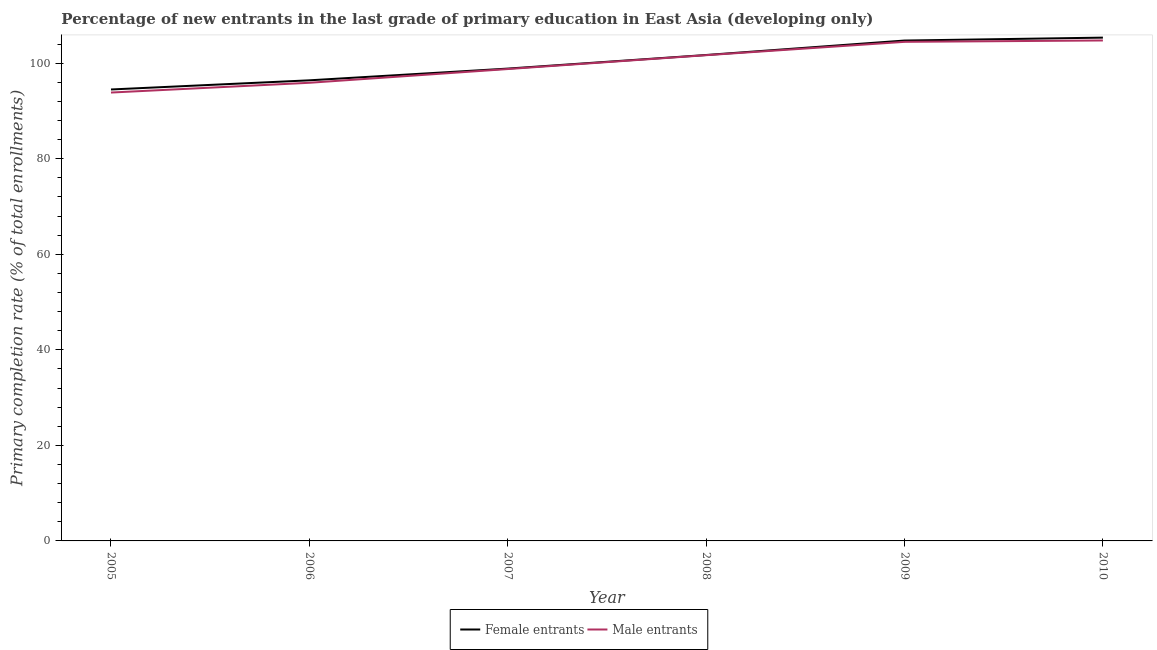Does the line corresponding to primary completion rate of female entrants intersect with the line corresponding to primary completion rate of male entrants?
Provide a short and direct response. No. Is the number of lines equal to the number of legend labels?
Your answer should be very brief. Yes. What is the primary completion rate of female entrants in 2009?
Your answer should be very brief. 104.75. Across all years, what is the maximum primary completion rate of male entrants?
Provide a short and direct response. 104.76. Across all years, what is the minimum primary completion rate of female entrants?
Ensure brevity in your answer.  94.5. In which year was the primary completion rate of female entrants maximum?
Your answer should be compact. 2010. What is the total primary completion rate of female entrants in the graph?
Your response must be concise. 601.63. What is the difference between the primary completion rate of male entrants in 2007 and that in 2009?
Make the answer very short. -5.69. What is the difference between the primary completion rate of male entrants in 2009 and the primary completion rate of female entrants in 2006?
Ensure brevity in your answer.  8.05. What is the average primary completion rate of female entrants per year?
Give a very brief answer. 100.27. In the year 2007, what is the difference between the primary completion rate of female entrants and primary completion rate of male entrants?
Your answer should be compact. 0.1. What is the ratio of the primary completion rate of female entrants in 2005 to that in 2008?
Provide a succinct answer. 0.93. Is the primary completion rate of male entrants in 2006 less than that in 2008?
Give a very brief answer. Yes. Is the difference between the primary completion rate of female entrants in 2007 and 2010 greater than the difference between the primary completion rate of male entrants in 2007 and 2010?
Ensure brevity in your answer.  No. What is the difference between the highest and the second highest primary completion rate of male entrants?
Your answer should be very brief. 0.29. What is the difference between the highest and the lowest primary completion rate of male entrants?
Your response must be concise. 10.9. Does the primary completion rate of male entrants monotonically increase over the years?
Provide a short and direct response. Yes. Is the primary completion rate of female entrants strictly less than the primary completion rate of male entrants over the years?
Provide a short and direct response. No. How many years are there in the graph?
Provide a succinct answer. 6. What is the difference between two consecutive major ticks on the Y-axis?
Provide a short and direct response. 20. Are the values on the major ticks of Y-axis written in scientific E-notation?
Ensure brevity in your answer.  No. Does the graph contain any zero values?
Your response must be concise. No. How are the legend labels stacked?
Provide a succinct answer. Horizontal. What is the title of the graph?
Offer a very short reply. Percentage of new entrants in the last grade of primary education in East Asia (developing only). What is the label or title of the X-axis?
Ensure brevity in your answer.  Year. What is the label or title of the Y-axis?
Ensure brevity in your answer.  Primary completion rate (% of total enrollments). What is the Primary completion rate (% of total enrollments) in Female entrants in 2005?
Ensure brevity in your answer.  94.5. What is the Primary completion rate (% of total enrollments) in Male entrants in 2005?
Provide a short and direct response. 93.86. What is the Primary completion rate (% of total enrollments) of Female entrants in 2006?
Ensure brevity in your answer.  96.42. What is the Primary completion rate (% of total enrollments) of Male entrants in 2006?
Your response must be concise. 95.91. What is the Primary completion rate (% of total enrollments) in Female entrants in 2007?
Keep it short and to the point. 98.88. What is the Primary completion rate (% of total enrollments) in Male entrants in 2007?
Your answer should be compact. 98.78. What is the Primary completion rate (% of total enrollments) of Female entrants in 2008?
Your answer should be compact. 101.72. What is the Primary completion rate (% of total enrollments) of Male entrants in 2008?
Give a very brief answer. 101.68. What is the Primary completion rate (% of total enrollments) of Female entrants in 2009?
Ensure brevity in your answer.  104.75. What is the Primary completion rate (% of total enrollments) in Male entrants in 2009?
Give a very brief answer. 104.48. What is the Primary completion rate (% of total enrollments) in Female entrants in 2010?
Ensure brevity in your answer.  105.36. What is the Primary completion rate (% of total enrollments) in Male entrants in 2010?
Keep it short and to the point. 104.76. Across all years, what is the maximum Primary completion rate (% of total enrollments) in Female entrants?
Your response must be concise. 105.36. Across all years, what is the maximum Primary completion rate (% of total enrollments) in Male entrants?
Offer a very short reply. 104.76. Across all years, what is the minimum Primary completion rate (% of total enrollments) in Female entrants?
Offer a very short reply. 94.5. Across all years, what is the minimum Primary completion rate (% of total enrollments) in Male entrants?
Give a very brief answer. 93.86. What is the total Primary completion rate (% of total enrollments) in Female entrants in the graph?
Your answer should be very brief. 601.63. What is the total Primary completion rate (% of total enrollments) of Male entrants in the graph?
Your answer should be very brief. 599.47. What is the difference between the Primary completion rate (% of total enrollments) of Female entrants in 2005 and that in 2006?
Your answer should be compact. -1.92. What is the difference between the Primary completion rate (% of total enrollments) of Male entrants in 2005 and that in 2006?
Provide a succinct answer. -2.04. What is the difference between the Primary completion rate (% of total enrollments) of Female entrants in 2005 and that in 2007?
Offer a very short reply. -4.37. What is the difference between the Primary completion rate (% of total enrollments) of Male entrants in 2005 and that in 2007?
Ensure brevity in your answer.  -4.92. What is the difference between the Primary completion rate (% of total enrollments) in Female entrants in 2005 and that in 2008?
Offer a terse response. -7.22. What is the difference between the Primary completion rate (% of total enrollments) of Male entrants in 2005 and that in 2008?
Make the answer very short. -7.82. What is the difference between the Primary completion rate (% of total enrollments) of Female entrants in 2005 and that in 2009?
Give a very brief answer. -10.24. What is the difference between the Primary completion rate (% of total enrollments) of Male entrants in 2005 and that in 2009?
Your answer should be very brief. -10.61. What is the difference between the Primary completion rate (% of total enrollments) of Female entrants in 2005 and that in 2010?
Ensure brevity in your answer.  -10.86. What is the difference between the Primary completion rate (% of total enrollments) of Male entrants in 2005 and that in 2010?
Your answer should be compact. -10.9. What is the difference between the Primary completion rate (% of total enrollments) of Female entrants in 2006 and that in 2007?
Keep it short and to the point. -2.46. What is the difference between the Primary completion rate (% of total enrollments) in Male entrants in 2006 and that in 2007?
Give a very brief answer. -2.88. What is the difference between the Primary completion rate (% of total enrollments) of Female entrants in 2006 and that in 2008?
Offer a terse response. -5.3. What is the difference between the Primary completion rate (% of total enrollments) in Male entrants in 2006 and that in 2008?
Your answer should be very brief. -5.78. What is the difference between the Primary completion rate (% of total enrollments) in Female entrants in 2006 and that in 2009?
Offer a terse response. -8.33. What is the difference between the Primary completion rate (% of total enrollments) in Male entrants in 2006 and that in 2009?
Make the answer very short. -8.57. What is the difference between the Primary completion rate (% of total enrollments) of Female entrants in 2006 and that in 2010?
Keep it short and to the point. -8.94. What is the difference between the Primary completion rate (% of total enrollments) of Male entrants in 2006 and that in 2010?
Provide a short and direct response. -8.86. What is the difference between the Primary completion rate (% of total enrollments) in Female entrants in 2007 and that in 2008?
Your answer should be very brief. -2.85. What is the difference between the Primary completion rate (% of total enrollments) of Male entrants in 2007 and that in 2008?
Ensure brevity in your answer.  -2.9. What is the difference between the Primary completion rate (% of total enrollments) of Female entrants in 2007 and that in 2009?
Your answer should be very brief. -5.87. What is the difference between the Primary completion rate (% of total enrollments) in Male entrants in 2007 and that in 2009?
Offer a terse response. -5.69. What is the difference between the Primary completion rate (% of total enrollments) of Female entrants in 2007 and that in 2010?
Offer a very short reply. -6.48. What is the difference between the Primary completion rate (% of total enrollments) of Male entrants in 2007 and that in 2010?
Provide a short and direct response. -5.98. What is the difference between the Primary completion rate (% of total enrollments) of Female entrants in 2008 and that in 2009?
Make the answer very short. -3.02. What is the difference between the Primary completion rate (% of total enrollments) in Male entrants in 2008 and that in 2009?
Give a very brief answer. -2.79. What is the difference between the Primary completion rate (% of total enrollments) of Female entrants in 2008 and that in 2010?
Your response must be concise. -3.64. What is the difference between the Primary completion rate (% of total enrollments) in Male entrants in 2008 and that in 2010?
Your response must be concise. -3.08. What is the difference between the Primary completion rate (% of total enrollments) of Female entrants in 2009 and that in 2010?
Give a very brief answer. -0.61. What is the difference between the Primary completion rate (% of total enrollments) in Male entrants in 2009 and that in 2010?
Your answer should be compact. -0.29. What is the difference between the Primary completion rate (% of total enrollments) in Female entrants in 2005 and the Primary completion rate (% of total enrollments) in Male entrants in 2006?
Give a very brief answer. -1.4. What is the difference between the Primary completion rate (% of total enrollments) of Female entrants in 2005 and the Primary completion rate (% of total enrollments) of Male entrants in 2007?
Make the answer very short. -4.28. What is the difference between the Primary completion rate (% of total enrollments) of Female entrants in 2005 and the Primary completion rate (% of total enrollments) of Male entrants in 2008?
Offer a very short reply. -7.18. What is the difference between the Primary completion rate (% of total enrollments) of Female entrants in 2005 and the Primary completion rate (% of total enrollments) of Male entrants in 2009?
Offer a very short reply. -9.97. What is the difference between the Primary completion rate (% of total enrollments) in Female entrants in 2005 and the Primary completion rate (% of total enrollments) in Male entrants in 2010?
Offer a terse response. -10.26. What is the difference between the Primary completion rate (% of total enrollments) in Female entrants in 2006 and the Primary completion rate (% of total enrollments) in Male entrants in 2007?
Provide a succinct answer. -2.36. What is the difference between the Primary completion rate (% of total enrollments) of Female entrants in 2006 and the Primary completion rate (% of total enrollments) of Male entrants in 2008?
Provide a short and direct response. -5.26. What is the difference between the Primary completion rate (% of total enrollments) of Female entrants in 2006 and the Primary completion rate (% of total enrollments) of Male entrants in 2009?
Give a very brief answer. -8.05. What is the difference between the Primary completion rate (% of total enrollments) of Female entrants in 2006 and the Primary completion rate (% of total enrollments) of Male entrants in 2010?
Offer a terse response. -8.34. What is the difference between the Primary completion rate (% of total enrollments) of Female entrants in 2007 and the Primary completion rate (% of total enrollments) of Male entrants in 2008?
Your answer should be compact. -2.81. What is the difference between the Primary completion rate (% of total enrollments) of Female entrants in 2007 and the Primary completion rate (% of total enrollments) of Male entrants in 2009?
Your answer should be compact. -5.6. What is the difference between the Primary completion rate (% of total enrollments) of Female entrants in 2007 and the Primary completion rate (% of total enrollments) of Male entrants in 2010?
Your answer should be very brief. -5.89. What is the difference between the Primary completion rate (% of total enrollments) of Female entrants in 2008 and the Primary completion rate (% of total enrollments) of Male entrants in 2009?
Provide a short and direct response. -2.75. What is the difference between the Primary completion rate (% of total enrollments) in Female entrants in 2008 and the Primary completion rate (% of total enrollments) in Male entrants in 2010?
Your answer should be compact. -3.04. What is the difference between the Primary completion rate (% of total enrollments) in Female entrants in 2009 and the Primary completion rate (% of total enrollments) in Male entrants in 2010?
Your answer should be very brief. -0.02. What is the average Primary completion rate (% of total enrollments) of Female entrants per year?
Provide a succinct answer. 100.27. What is the average Primary completion rate (% of total enrollments) of Male entrants per year?
Your answer should be very brief. 99.91. In the year 2005, what is the difference between the Primary completion rate (% of total enrollments) in Female entrants and Primary completion rate (% of total enrollments) in Male entrants?
Offer a very short reply. 0.64. In the year 2006, what is the difference between the Primary completion rate (% of total enrollments) in Female entrants and Primary completion rate (% of total enrollments) in Male entrants?
Give a very brief answer. 0.52. In the year 2007, what is the difference between the Primary completion rate (% of total enrollments) in Female entrants and Primary completion rate (% of total enrollments) in Male entrants?
Your answer should be compact. 0.1. In the year 2008, what is the difference between the Primary completion rate (% of total enrollments) of Female entrants and Primary completion rate (% of total enrollments) of Male entrants?
Your answer should be very brief. 0.04. In the year 2009, what is the difference between the Primary completion rate (% of total enrollments) in Female entrants and Primary completion rate (% of total enrollments) in Male entrants?
Offer a very short reply. 0.27. In the year 2010, what is the difference between the Primary completion rate (% of total enrollments) in Female entrants and Primary completion rate (% of total enrollments) in Male entrants?
Make the answer very short. 0.6. What is the ratio of the Primary completion rate (% of total enrollments) in Female entrants in 2005 to that in 2006?
Offer a very short reply. 0.98. What is the ratio of the Primary completion rate (% of total enrollments) of Male entrants in 2005 to that in 2006?
Provide a succinct answer. 0.98. What is the ratio of the Primary completion rate (% of total enrollments) of Female entrants in 2005 to that in 2007?
Your answer should be very brief. 0.96. What is the ratio of the Primary completion rate (% of total enrollments) of Male entrants in 2005 to that in 2007?
Provide a short and direct response. 0.95. What is the ratio of the Primary completion rate (% of total enrollments) in Female entrants in 2005 to that in 2008?
Ensure brevity in your answer.  0.93. What is the ratio of the Primary completion rate (% of total enrollments) of Male entrants in 2005 to that in 2008?
Provide a succinct answer. 0.92. What is the ratio of the Primary completion rate (% of total enrollments) of Female entrants in 2005 to that in 2009?
Give a very brief answer. 0.9. What is the ratio of the Primary completion rate (% of total enrollments) in Male entrants in 2005 to that in 2009?
Keep it short and to the point. 0.9. What is the ratio of the Primary completion rate (% of total enrollments) of Female entrants in 2005 to that in 2010?
Offer a very short reply. 0.9. What is the ratio of the Primary completion rate (% of total enrollments) of Male entrants in 2005 to that in 2010?
Offer a very short reply. 0.9. What is the ratio of the Primary completion rate (% of total enrollments) in Female entrants in 2006 to that in 2007?
Ensure brevity in your answer.  0.98. What is the ratio of the Primary completion rate (% of total enrollments) of Male entrants in 2006 to that in 2007?
Your answer should be compact. 0.97. What is the ratio of the Primary completion rate (% of total enrollments) in Female entrants in 2006 to that in 2008?
Your answer should be very brief. 0.95. What is the ratio of the Primary completion rate (% of total enrollments) in Male entrants in 2006 to that in 2008?
Provide a succinct answer. 0.94. What is the ratio of the Primary completion rate (% of total enrollments) of Female entrants in 2006 to that in 2009?
Your response must be concise. 0.92. What is the ratio of the Primary completion rate (% of total enrollments) in Male entrants in 2006 to that in 2009?
Ensure brevity in your answer.  0.92. What is the ratio of the Primary completion rate (% of total enrollments) in Female entrants in 2006 to that in 2010?
Make the answer very short. 0.92. What is the ratio of the Primary completion rate (% of total enrollments) of Male entrants in 2006 to that in 2010?
Provide a succinct answer. 0.92. What is the ratio of the Primary completion rate (% of total enrollments) of Male entrants in 2007 to that in 2008?
Provide a short and direct response. 0.97. What is the ratio of the Primary completion rate (% of total enrollments) in Female entrants in 2007 to that in 2009?
Provide a succinct answer. 0.94. What is the ratio of the Primary completion rate (% of total enrollments) in Male entrants in 2007 to that in 2009?
Give a very brief answer. 0.95. What is the ratio of the Primary completion rate (% of total enrollments) in Female entrants in 2007 to that in 2010?
Your answer should be compact. 0.94. What is the ratio of the Primary completion rate (% of total enrollments) of Male entrants in 2007 to that in 2010?
Make the answer very short. 0.94. What is the ratio of the Primary completion rate (% of total enrollments) of Female entrants in 2008 to that in 2009?
Ensure brevity in your answer.  0.97. What is the ratio of the Primary completion rate (% of total enrollments) in Male entrants in 2008 to that in 2009?
Keep it short and to the point. 0.97. What is the ratio of the Primary completion rate (% of total enrollments) in Female entrants in 2008 to that in 2010?
Make the answer very short. 0.97. What is the ratio of the Primary completion rate (% of total enrollments) in Male entrants in 2008 to that in 2010?
Keep it short and to the point. 0.97. What is the ratio of the Primary completion rate (% of total enrollments) in Female entrants in 2009 to that in 2010?
Your response must be concise. 0.99. What is the ratio of the Primary completion rate (% of total enrollments) in Male entrants in 2009 to that in 2010?
Your answer should be very brief. 1. What is the difference between the highest and the second highest Primary completion rate (% of total enrollments) in Female entrants?
Give a very brief answer. 0.61. What is the difference between the highest and the second highest Primary completion rate (% of total enrollments) of Male entrants?
Your answer should be compact. 0.29. What is the difference between the highest and the lowest Primary completion rate (% of total enrollments) of Female entrants?
Provide a succinct answer. 10.86. What is the difference between the highest and the lowest Primary completion rate (% of total enrollments) in Male entrants?
Keep it short and to the point. 10.9. 